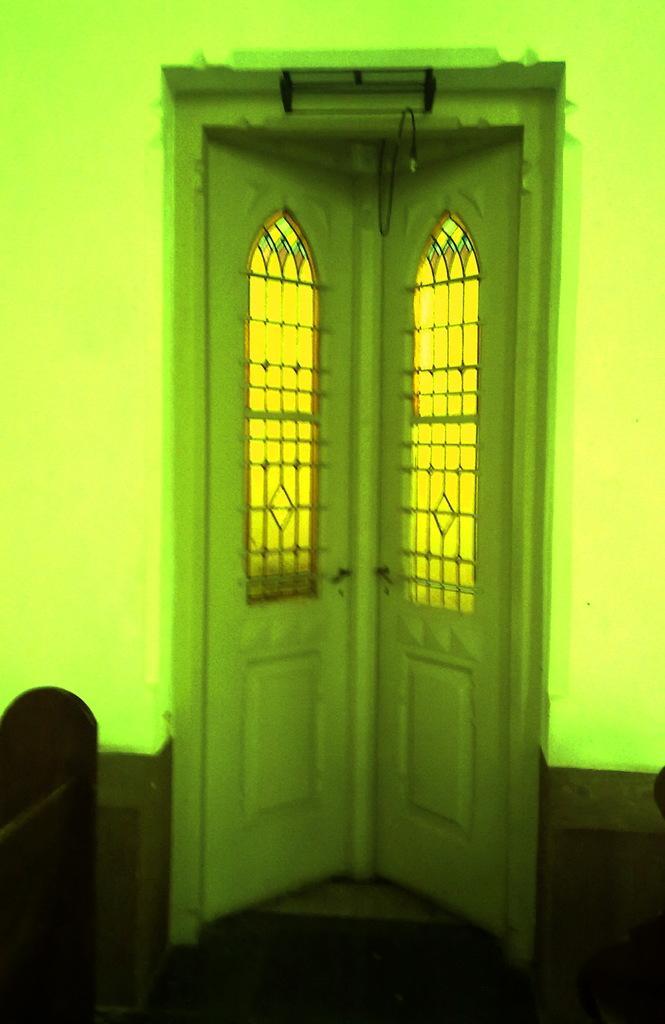Could you give a brief overview of what you see in this image? In this picture there is a door, beside that I can see the wall. In the bottom left I can see the wooden object. 